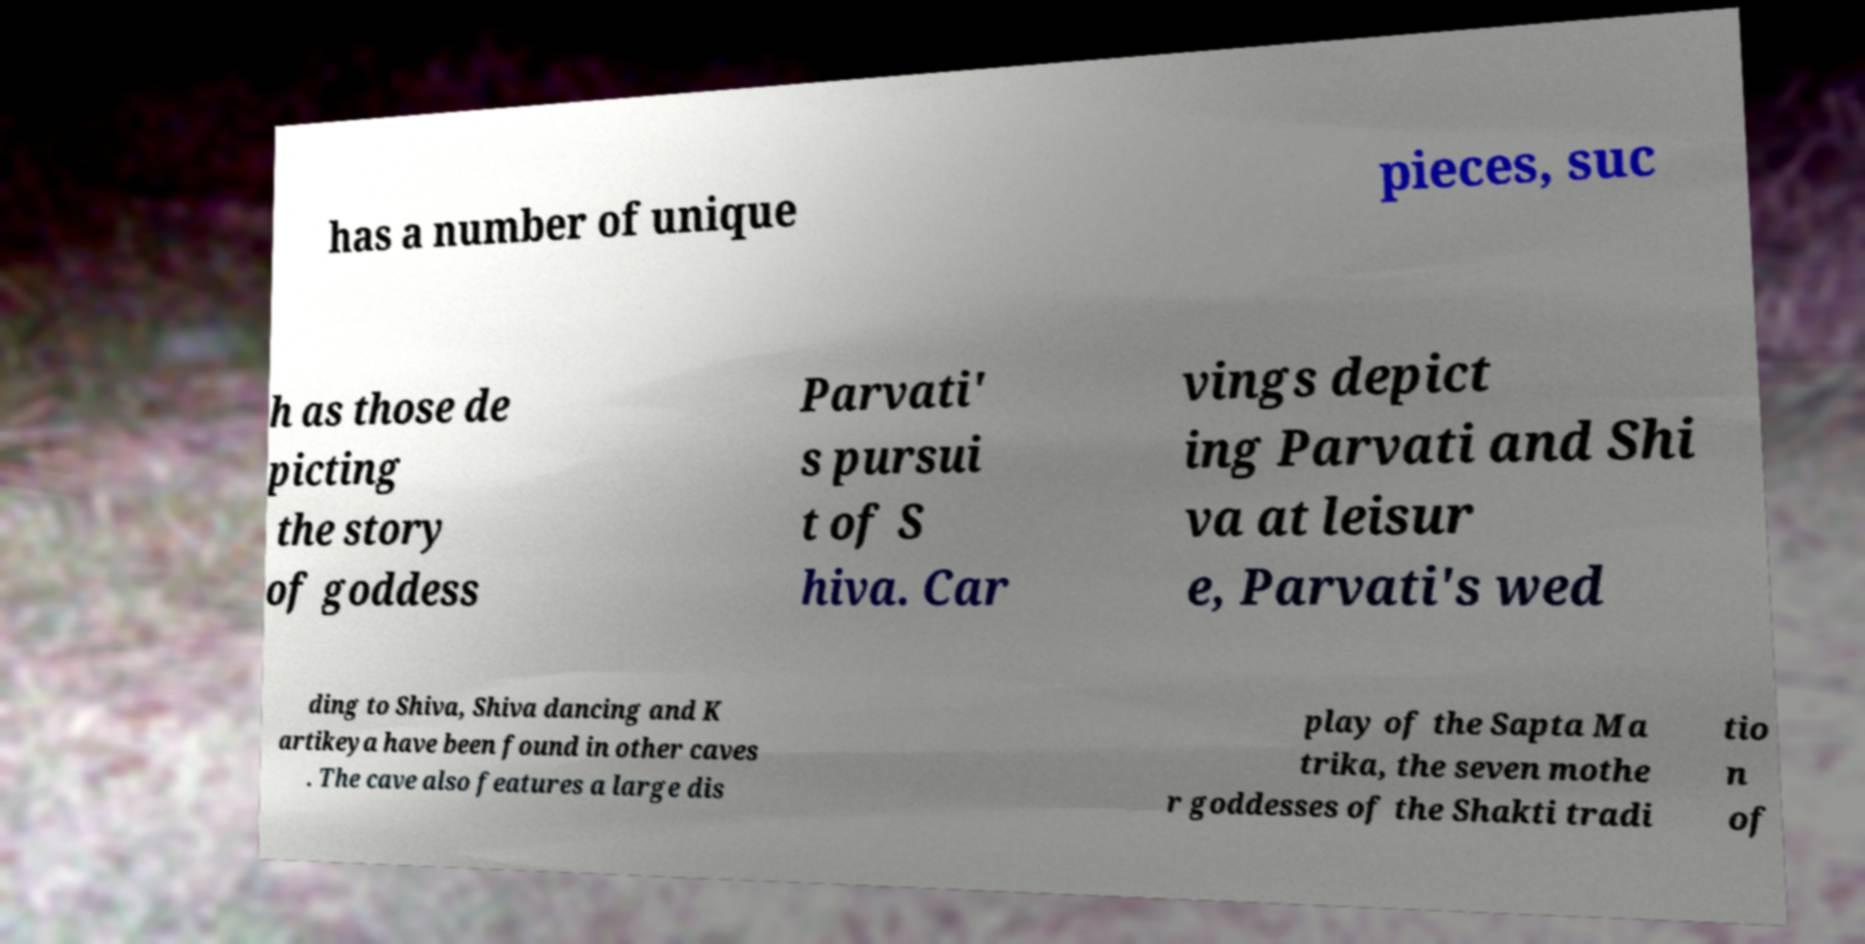For documentation purposes, I need the text within this image transcribed. Could you provide that? has a number of unique pieces, suc h as those de picting the story of goddess Parvati' s pursui t of S hiva. Car vings depict ing Parvati and Shi va at leisur e, Parvati's wed ding to Shiva, Shiva dancing and K artikeya have been found in other caves . The cave also features a large dis play of the Sapta Ma trika, the seven mothe r goddesses of the Shakti tradi tio n of 